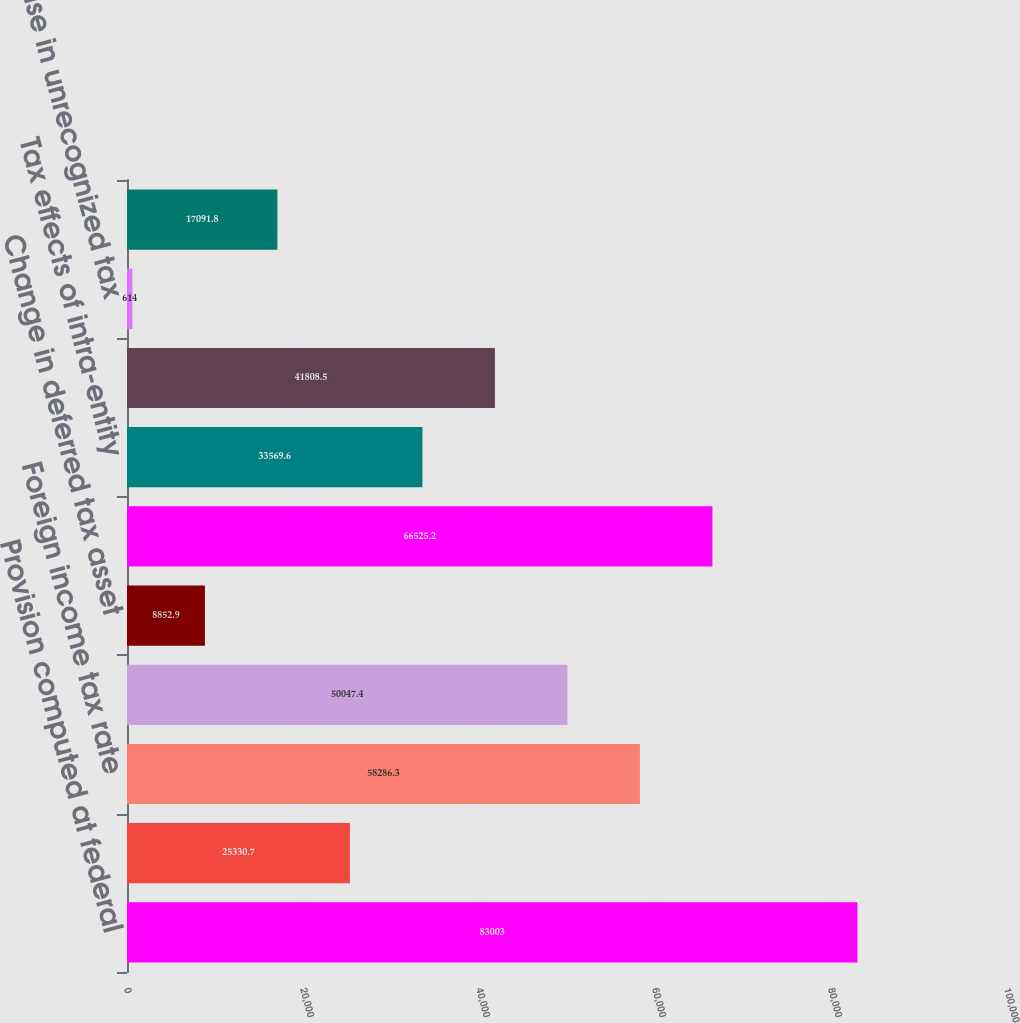Convert chart to OTSL. <chart><loc_0><loc_0><loc_500><loc_500><bar_chart><fcel>Provision computed at federal<fcel>State and local income tax net<fcel>Foreign income tax rate<fcel>Stock-based compensation<fcel>Change in deferred tax asset<fcel>Tax credits<fcel>Tax effects of intra-entity<fcel>Withholding taxes<fcel>Increase in unrecognized tax<fcel>Other<nl><fcel>83003<fcel>25330.7<fcel>58286.3<fcel>50047.4<fcel>8852.9<fcel>66525.2<fcel>33569.6<fcel>41808.5<fcel>614<fcel>17091.8<nl></chart> 